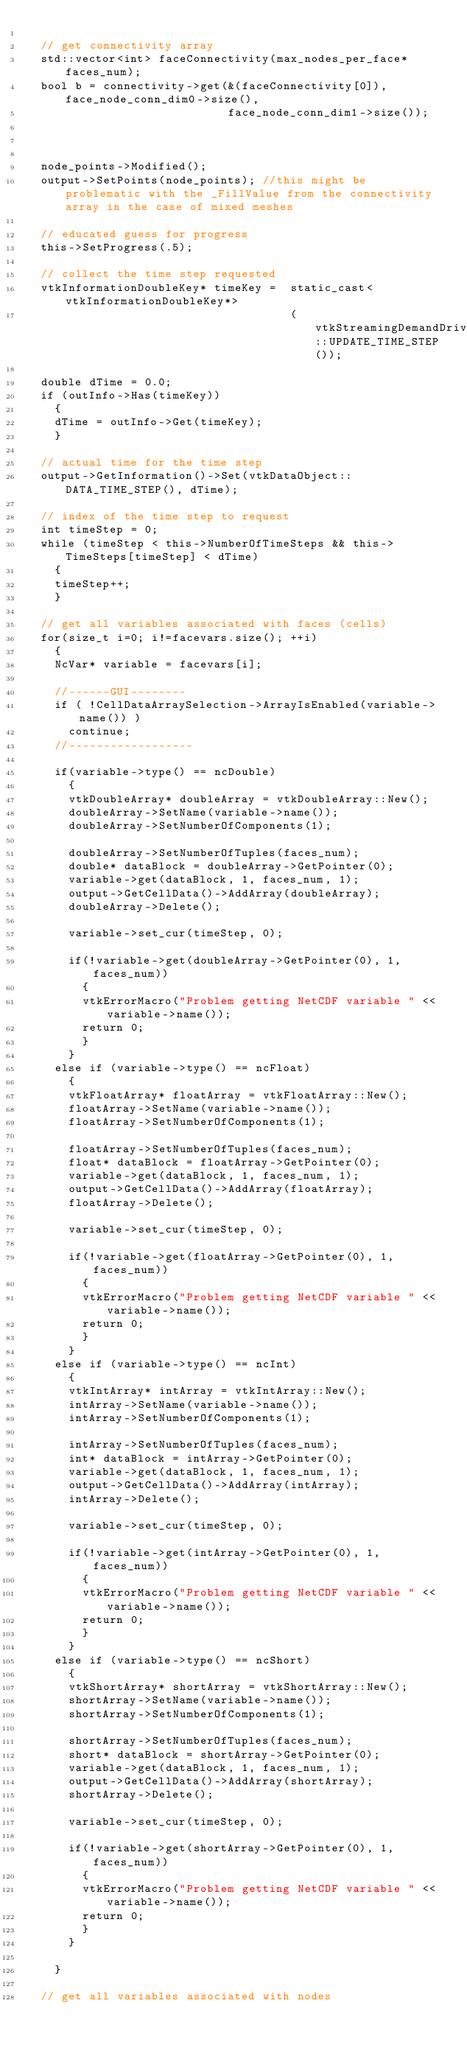<code> <loc_0><loc_0><loc_500><loc_500><_C++_>
  // get connectivity array
  std::vector<int> faceConnectivity(max_nodes_per_face*faces_num);
  bool b = connectivity->get(&(faceConnectivity[0]), face_node_conn_dim0->size(),
                             face_node_conn_dim1->size());



  node_points->Modified();
  output->SetPoints(node_points); //this might be problematic with the _FillValue from the connectivity array in the case of mixed meshes

  // educated guess for progress
  this->SetProgress(.5);

  // collect the time step requested
  vtkInformationDoubleKey* timeKey =  static_cast<vtkInformationDoubleKey*>
                                      (vtkStreamingDemandDrivenPipeline::UPDATE_TIME_STEP());

  double dTime = 0.0;
  if (outInfo->Has(timeKey))
    {
    dTime = outInfo->Get(timeKey);
    }

  // actual time for the time step
  output->GetInformation()->Set(vtkDataObject::DATA_TIME_STEP(), dTime);

  // index of the time step to request
  int timeStep = 0;
  while (timeStep < this->NumberOfTimeSteps && this->TimeSteps[timeStep] < dTime)
    {
    timeStep++;
    }

  // get all variables associated with faces (cells)
  for(size_t i=0; i!=facevars.size(); ++i)
    {
    NcVar* variable = facevars[i];

    //------GUI--------
    if ( !CellDataArraySelection->ArrayIsEnabled(variable->name()) )
      continue;
    //------------------

    if(variable->type() == ncDouble)
      {
      vtkDoubleArray* doubleArray = vtkDoubleArray::New();
      doubleArray->SetName(variable->name());
      doubleArray->SetNumberOfComponents(1);

      doubleArray->SetNumberOfTuples(faces_num);
      double* dataBlock = doubleArray->GetPointer(0);
      variable->get(dataBlock, 1, faces_num, 1);
      output->GetCellData()->AddArray(doubleArray);
      doubleArray->Delete();

      variable->set_cur(timeStep, 0);

      if(!variable->get(doubleArray->GetPointer(0), 1, faces_num))
        {
        vtkErrorMacro("Problem getting NetCDF variable " << variable->name());
        return 0;
        }
      }
    else if (variable->type() == ncFloat)
      {
      vtkFloatArray* floatArray = vtkFloatArray::New();
      floatArray->SetName(variable->name());
      floatArray->SetNumberOfComponents(1);

      floatArray->SetNumberOfTuples(faces_num);
      float* dataBlock = floatArray->GetPointer(0);
      variable->get(dataBlock, 1, faces_num, 1);
      output->GetCellData()->AddArray(floatArray);
      floatArray->Delete();

      variable->set_cur(timeStep, 0);

      if(!variable->get(floatArray->GetPointer(0), 1, faces_num))
        {
        vtkErrorMacro("Problem getting NetCDF variable " << variable->name());
        return 0;
        }
      }
    else if (variable->type() == ncInt)
      {
      vtkIntArray* intArray = vtkIntArray::New();
      intArray->SetName(variable->name());
      intArray->SetNumberOfComponents(1);

      intArray->SetNumberOfTuples(faces_num);
      int* dataBlock = intArray->GetPointer(0);
      variable->get(dataBlock, 1, faces_num, 1);
      output->GetCellData()->AddArray(intArray);
      intArray->Delete();

      variable->set_cur(timeStep, 0);

      if(!variable->get(intArray->GetPointer(0), 1, faces_num))
        {
        vtkErrorMacro("Problem getting NetCDF variable " << variable->name());
        return 0;
        }
      }
    else if (variable->type() == ncShort)
      {
      vtkShortArray* shortArray = vtkShortArray::New();
      shortArray->SetName(variable->name());
      shortArray->SetNumberOfComponents(1);

      shortArray->SetNumberOfTuples(faces_num);
      short* dataBlock = shortArray->GetPointer(0);
      variable->get(dataBlock, 1, faces_num, 1);
      output->GetCellData()->AddArray(shortArray);
      shortArray->Delete();

      variable->set_cur(timeStep, 0);

      if(!variable->get(shortArray->GetPointer(0), 1, faces_num))
        {
        vtkErrorMacro("Problem getting NetCDF variable " << variable->name());
        return 0;
        }
      }

    }

  // get all variables associated with nodes</code> 